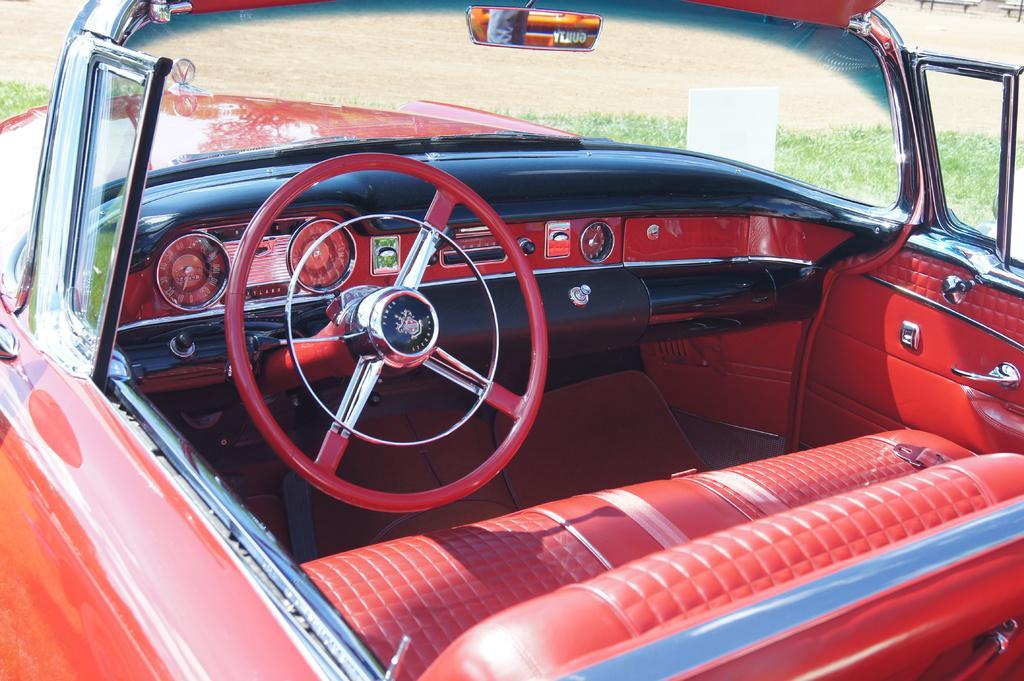In one or two sentences, can you explain what this image depicts? Here in this picture we can see a red colored car present on the ground, which is covered with grass over there and we can see the dashboard with speedometer and steering and music system on it over there and in the front we can see the windshield also present over there. 